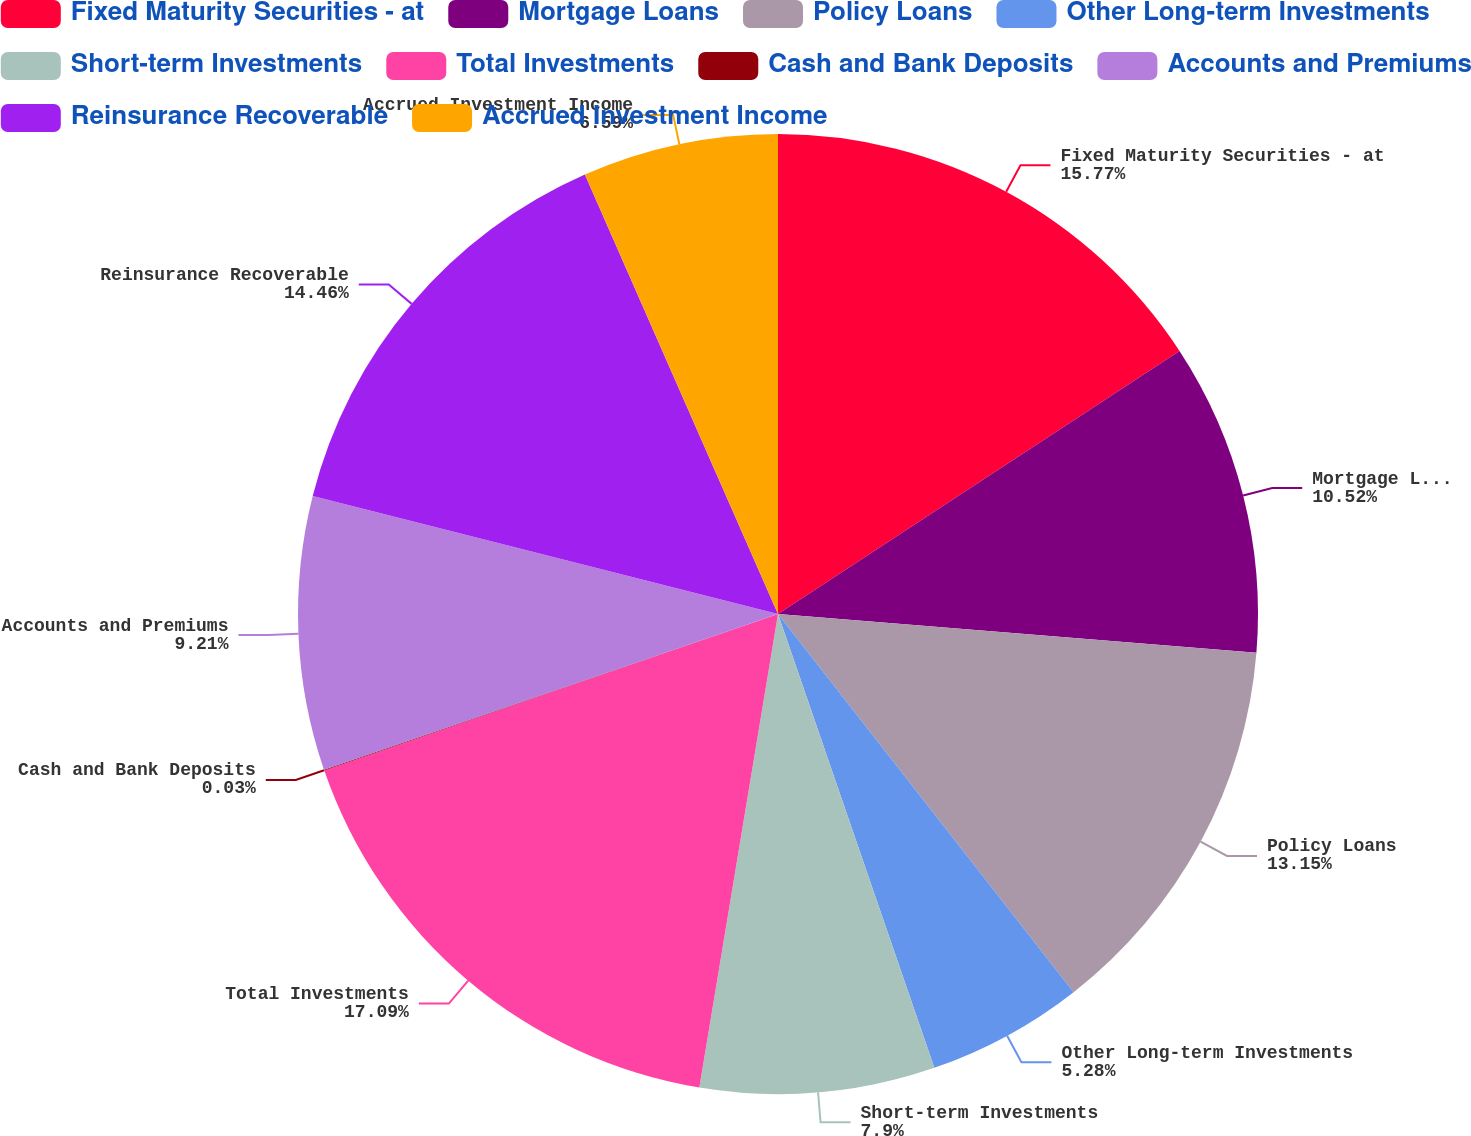Convert chart to OTSL. <chart><loc_0><loc_0><loc_500><loc_500><pie_chart><fcel>Fixed Maturity Securities - at<fcel>Mortgage Loans<fcel>Policy Loans<fcel>Other Long-term Investments<fcel>Short-term Investments<fcel>Total Investments<fcel>Cash and Bank Deposits<fcel>Accounts and Premiums<fcel>Reinsurance Recoverable<fcel>Accrued Investment Income<nl><fcel>15.77%<fcel>10.52%<fcel>13.15%<fcel>5.28%<fcel>7.9%<fcel>17.09%<fcel>0.03%<fcel>9.21%<fcel>14.46%<fcel>6.59%<nl></chart> 